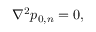<formula> <loc_0><loc_0><loc_500><loc_500>\begin{array} { r } { \nabla ^ { 2 } p _ { 0 , n } = 0 , } \end{array}</formula> 